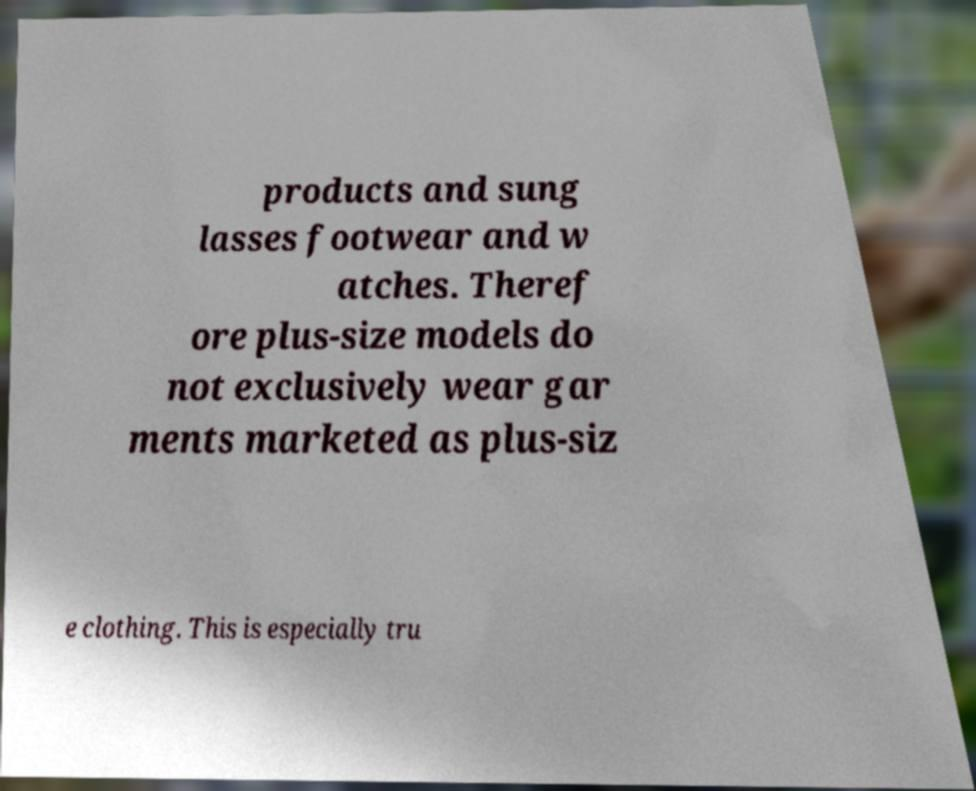I need the written content from this picture converted into text. Can you do that? products and sung lasses footwear and w atches. Theref ore plus-size models do not exclusively wear gar ments marketed as plus-siz e clothing. This is especially tru 